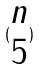<formula> <loc_0><loc_0><loc_500><loc_500>( \begin{matrix} n \\ 5 \end{matrix} )</formula> 